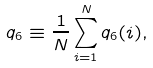<formula> <loc_0><loc_0><loc_500><loc_500>q _ { 6 } \equiv \frac { 1 } { N } \sum _ { i = 1 } ^ { N } q _ { 6 } ( i ) ,</formula> 